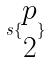Convert formula to latex. <formula><loc_0><loc_0><loc_500><loc_500>s \{ \begin{matrix} p \\ 2 \end{matrix} \}</formula> 